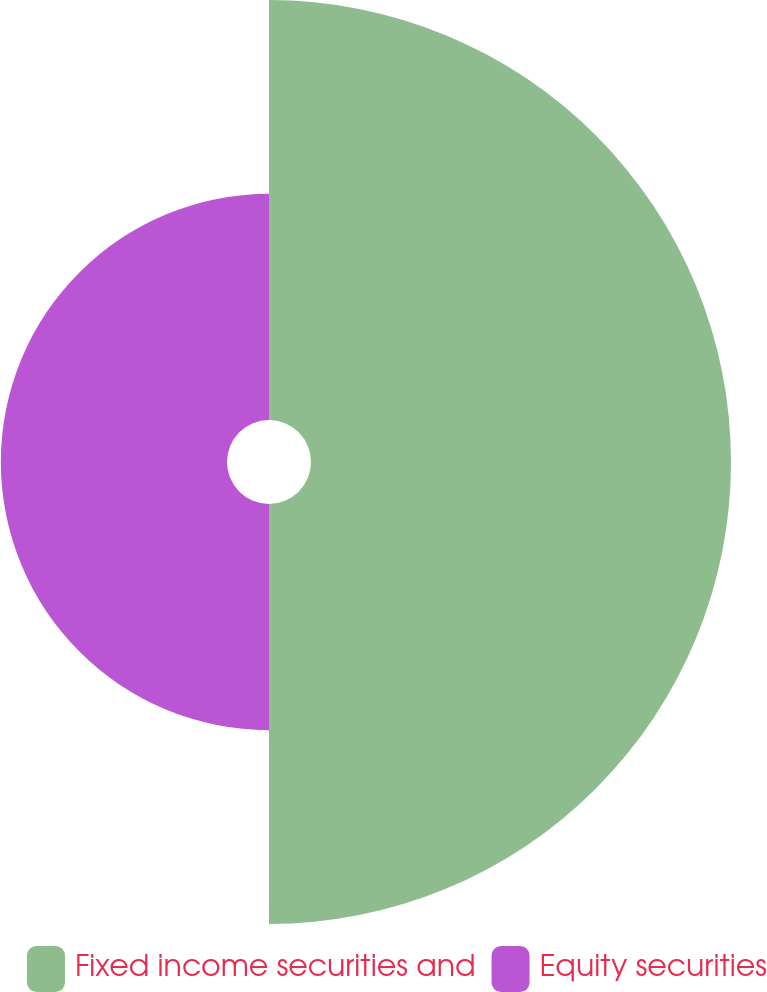Convert chart to OTSL. <chart><loc_0><loc_0><loc_500><loc_500><pie_chart><fcel>Fixed income securities and<fcel>Equity securities<nl><fcel>65.0%<fcel>35.0%<nl></chart> 